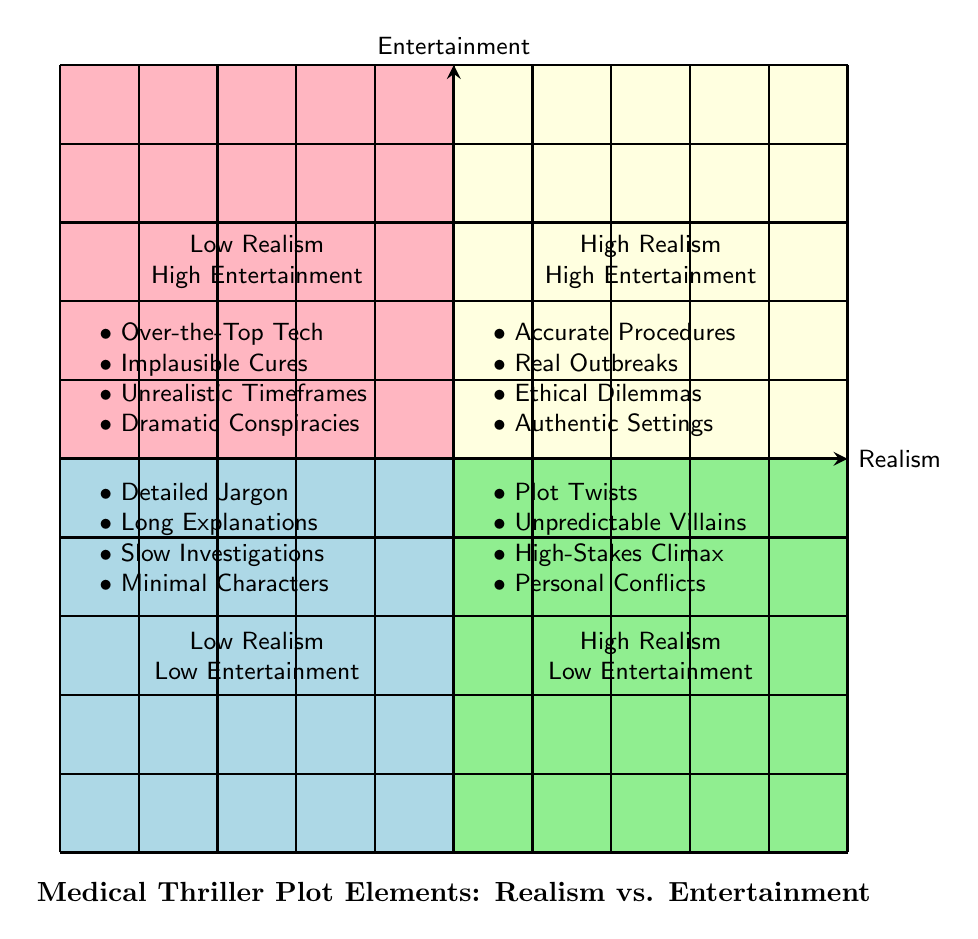What are the plot elements with Low Realism and High Entertainment? This quadrant contains elements that prioritize entertainment value over realistic depictions. These elements include "Over-the-Top Medical Technology," "Implausible Medical Cures," "Unrealistic Timeframes for Diagnosis and Treatment," and "Dramatic Conspiracies Involving Multiple Hospitals."
Answer: Over-the-Top Medical Technology, Implausible Medical Cures, Unrealistic Timeframes for Diagnosis and Treatment, Dramatic Conspiracies Involving Multiple Hospitals Which category includes "Accurate Medical Procedures"? "Accurate Medical Procedures" is listed in the quadrant labeled High Realism and High Entertainment, indicating it is a plot element that is both realistic and entertaining.
Answer: High Realism and High Entertainment How many elements are featured in the Low Realism and Low Entertainment quadrant? There are four elements in the Low Realism and Low Entertainment quadrant: "Detailed Medical Jargon," "Prolonged Medical Explanations," "Slow-Paced Investigations," and "Minimal Character Development."
Answer: 4 What characterizes the High Realism and Low Entertainment quadrant? This quadrant contains elements that are realistic but do not engage the audience as much. The plot elements listed are "Detailed Medical Jargon," "Prolonged Medical Explanations," "Slow-Paced Investigations," and "Minimal Character Development."
Answer: Detailed Medical Jargon, Prolonged Medical Explanations, Slow-Paced Investigations, Minimal Character Development Which plot elements are found in the High Entertainment quadrant? The High Entertainment quadrant features elements designed to captivate audiences, namely "Fast-Paced Plot Twists," "Unpredictable Antagonists," "High-Stakes Climax," and "Intense Personal Conflicts."
Answer: Fast-Paced Plot Twists, Unpredictable Antagonists, High-Stakes Climax, Intense Personal Conflicts What type of plot elements would you expect in the High Realism and High Entertainment quadrant? This quadrant combines the best of both worlds, including plot elements that are both entertaining and grounded in realism. It includes "Accurate Medical Procedures," "Real Disease Outbreak Scenarios," "Genuine Ethical Dilemmas," and "Authentic Hospital Settings."
Answer: Accurate Medical Procedures, Real Disease Outbreak Scenarios, Genuine Ethical Dilemmas, Authentic Hospital Settings What defines the relationship between Realism and Entertainment in this chart? The horizontal axis represents Realism, ranging from Low to High, while the vertical axis represents Entertainment, also ranging from Low to High, creating a matrix to categorize different plot elements based on their realism and entertainment quality.
Answer: A matrix categorizing plot elements based on Realism and Entertainment In which quadrant would you find "Unrealistic Timeframes for Diagnosis and Treatment"? "Unrealistic Timeframes for Diagnosis and Treatment" falls within the Low Realism and High Entertainment quadrant, indicating it is an element that enhances entertainment but lacks realism.
Answer: Low Realism and High Entertainment 